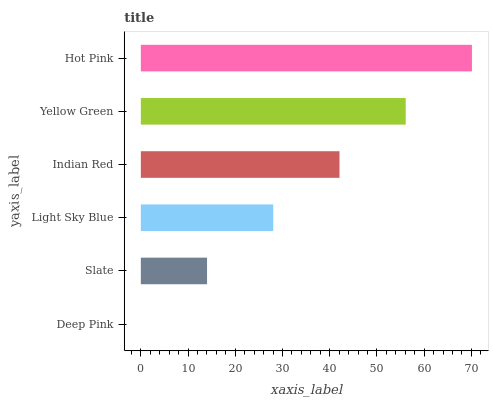Is Deep Pink the minimum?
Answer yes or no. Yes. Is Hot Pink the maximum?
Answer yes or no. Yes. Is Slate the minimum?
Answer yes or no. No. Is Slate the maximum?
Answer yes or no. No. Is Slate greater than Deep Pink?
Answer yes or no. Yes. Is Deep Pink less than Slate?
Answer yes or no. Yes. Is Deep Pink greater than Slate?
Answer yes or no. No. Is Slate less than Deep Pink?
Answer yes or no. No. Is Indian Red the high median?
Answer yes or no. Yes. Is Light Sky Blue the low median?
Answer yes or no. Yes. Is Hot Pink the high median?
Answer yes or no. No. Is Deep Pink the low median?
Answer yes or no. No. 